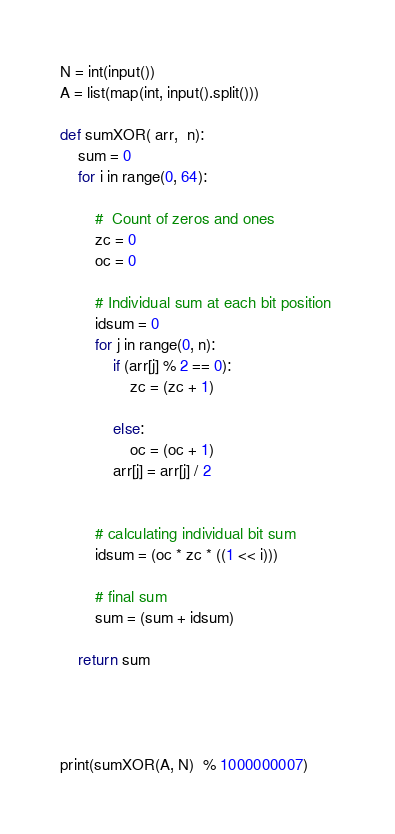<code> <loc_0><loc_0><loc_500><loc_500><_Python_>N = int(input())
A = list(map(int, input().split())) 

def sumXOR( arr,  n): 
    sum = 0
    for i in range(0, 64): 
  
        #  Count of zeros and ones 
        zc = 0
        oc = 0
           
        # Individual sum at each bit position 
        idsum = 0
        for j in range(0, n): 
            if (arr[j] % 2 == 0): 
                zc = (zc + 1)
                  
            else: 
                oc = (oc + 1)
            arr[j] = arr[j] / 2 
          
           
        # calculating individual bit sum  
        idsum = (oc * zc * ((1 << i)))
   
        # final sum     
        sum = (sum + idsum)
      
    return sum
  
  
  
  
print(sumXOR(A, N)  % 1000000007)</code> 